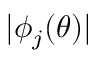<formula> <loc_0><loc_0><loc_500><loc_500>| \phi _ { j } ( \theta ) |</formula> 